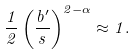<formula> <loc_0><loc_0><loc_500><loc_500>\frac { 1 } { 2 } \left ( \frac { b ^ { \prime } } { s } \right ) ^ { 2 - \alpha } \approx 1 .</formula> 